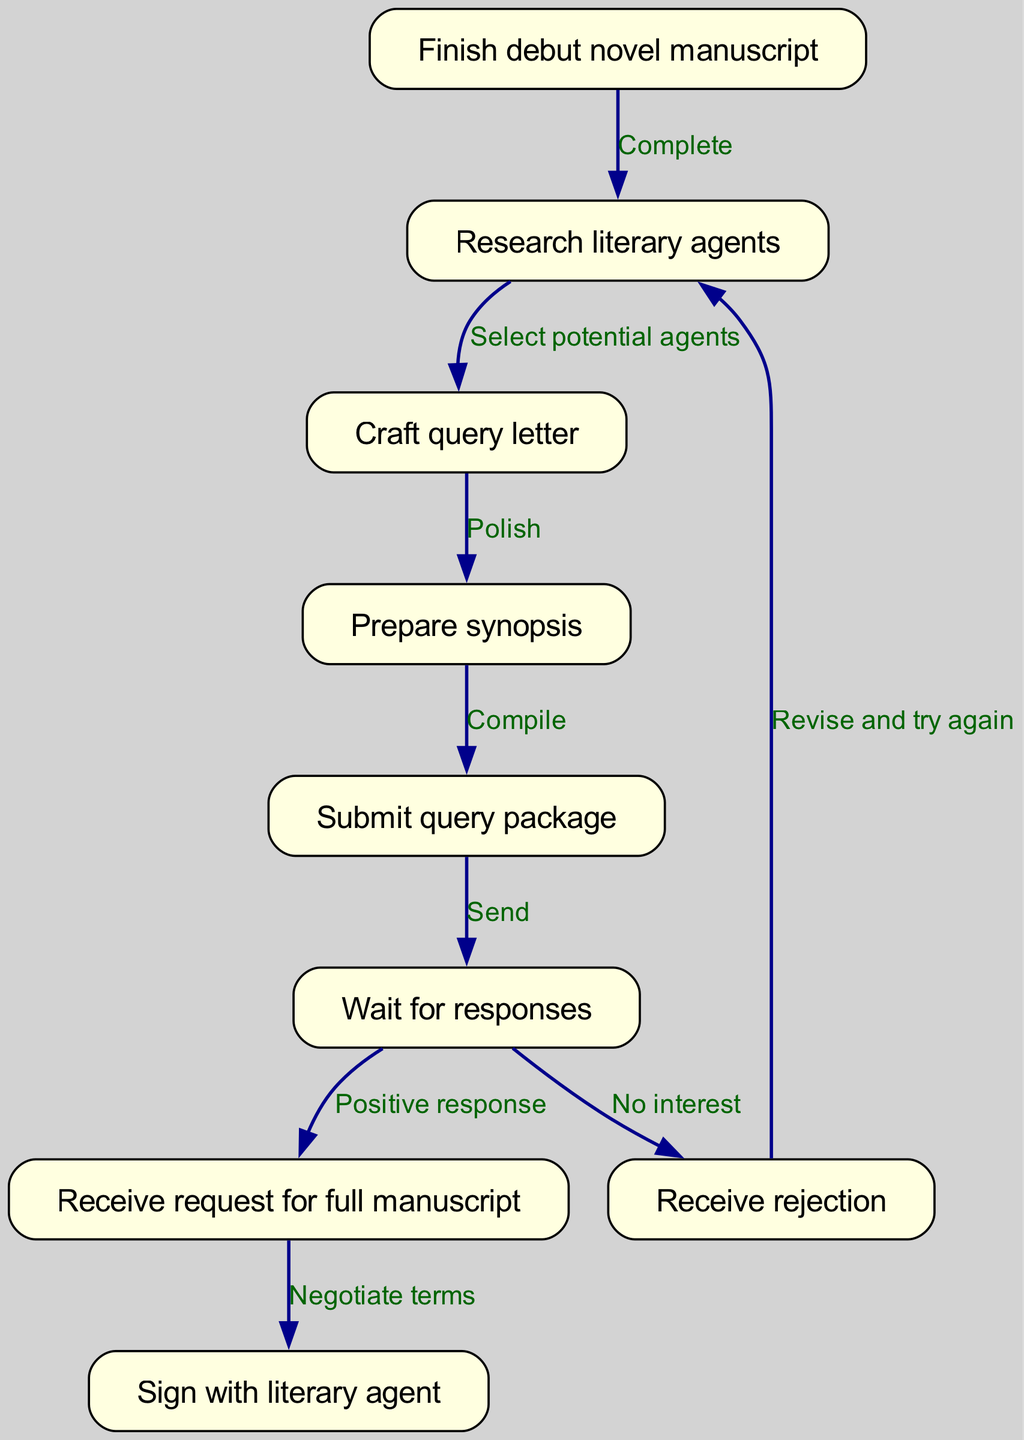What is the first step in the journey? The first node in the diagram indicates that the journey begins with finishing the debut novel manuscript. Therefore, the answer is found at the top of the flow chart.
Answer: Finish debut novel manuscript How many nodes are in the diagram? To determine the number of nodes, we can count each unique step in the flow chart. The diagram has 9 distinct steps or nodes listed.
Answer: 9 What happens after submitting the query package? The edge leading from "Submit query package" to "Wait for responses" indicates that the next step after submitting is to wait for responses from agents.
Answer: Wait for responses What response indicates further interest from a literary agent? The diagram shows a direct edge leading from "Wait for responses" to "Receive request for full manuscript," which signifies that such a request indicates the agent's interest.
Answer: Receive request for full manuscript What should you do if you receive a rejection? According to the diagram, if a rejection is received, the flow leads back to the step of researching literary agents, indicating that one should revise and try again.
Answer: Revise and try again After receiving a request for a full manuscript, what is the next step? The diagram shows a direct relationship between "Receive request for full manuscript" and "Sign with literary agent." Thus, the next step indicates moving towards negotiation of terms with the agent.
Answer: Negotiate terms What is the final outcome of this journey? The concluding node in the diagram is "Sign with literary agent," which indicates the successful outcome of the journey described in the flow chart.
Answer: Sign with literary agent 